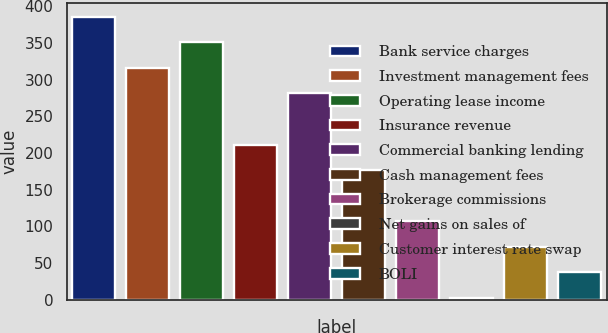<chart> <loc_0><loc_0><loc_500><loc_500><bar_chart><fcel>Bank service charges<fcel>Investment management fees<fcel>Operating lease income<fcel>Insurance revenue<fcel>Commercial banking lending<fcel>Cash management fees<fcel>Brokerage commissions<fcel>Net gains on sales of<fcel>Customer interest rate swap<fcel>BOLI<nl><fcel>385.59<fcel>316.01<fcel>350.8<fcel>211.64<fcel>281.22<fcel>176.85<fcel>107.27<fcel>2.9<fcel>72.48<fcel>37.69<nl></chart> 